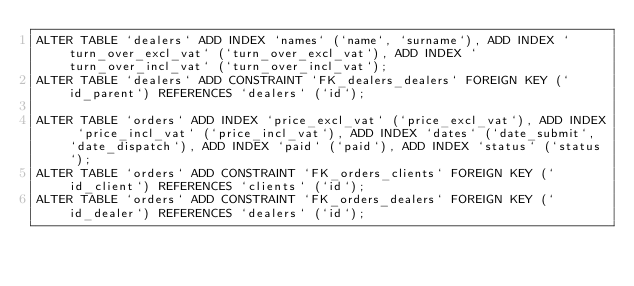Convert code to text. <code><loc_0><loc_0><loc_500><loc_500><_SQL_>ALTER TABLE `dealers` ADD INDEX `names` (`name`, `surname`), ADD INDEX `turn_over_excl_vat` (`turn_over_excl_vat`), ADD INDEX `turn_over_incl_vat` (`turn_over_incl_vat`);
ALTER TABLE `dealers` ADD CONSTRAINT `FK_dealers_dealers` FOREIGN KEY (`id_parent`) REFERENCES `dealers` (`id`);

ALTER TABLE `orders` ADD INDEX `price_excl_vat` (`price_excl_vat`), ADD INDEX `price_incl_vat` (`price_incl_vat`), ADD INDEX `dates` (`date_submit`, `date_dispatch`), ADD INDEX `paid` (`paid`), ADD INDEX `status` (`status`);
ALTER TABLE `orders` ADD CONSTRAINT `FK_orders_clients` FOREIGN KEY (`id_client`) REFERENCES `clients` (`id`);
ALTER TABLE `orders` ADD CONSTRAINT `FK_orders_dealers` FOREIGN KEY (`id_dealer`) REFERENCES `dealers` (`id`);</code> 